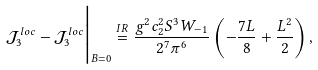<formula> <loc_0><loc_0><loc_500><loc_500>\mathcal { J } _ { 3 } ^ { l o c } - \mathcal { J } _ { 3 } ^ { l o c } \Big | _ { B = 0 } \stackrel { I R } { = } \frac { g ^ { 2 } c _ { 2 } ^ { 2 } S ^ { 3 } W _ { - 1 } } { 2 ^ { 7 } \pi ^ { 6 } } \left ( - \frac { 7 L } { 8 } + \frac { L ^ { 2 } } { 2 } \right ) ,</formula> 